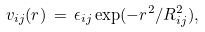<formula> <loc_0><loc_0><loc_500><loc_500>v _ { i j } ( r ) \, = \, \epsilon _ { i j } \exp ( - r ^ { 2 } / R _ { i j } ^ { 2 } ) ,</formula> 